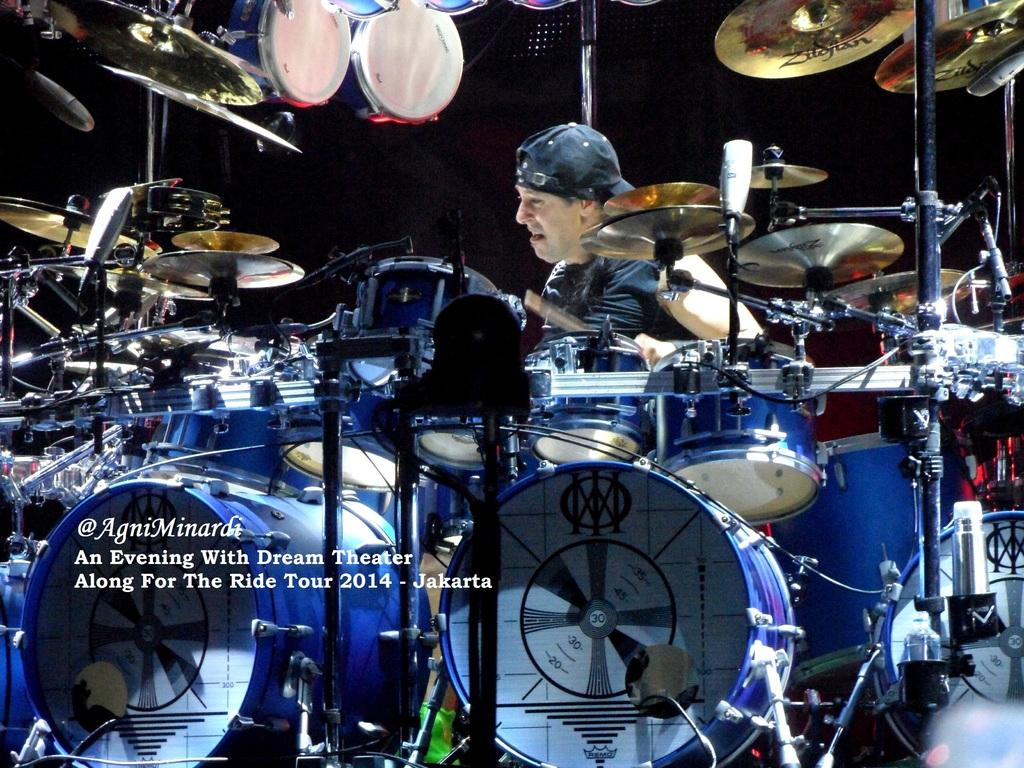What objects can be seen in the image related to music? There are musical instruments in the image. What else can be found in the image besides musical instruments? There is some text in the image. Can you describe the man's appearance in the image? A man is wearing a cap in the image. What is the color of the background in the image? The background of the image is dark. How many fairies are holding hands in the image? There are no fairies present in the image. What type of scene is depicted in the image? The image does not depict a specific scene; it features musical instruments, text, and a man wearing a cap. 